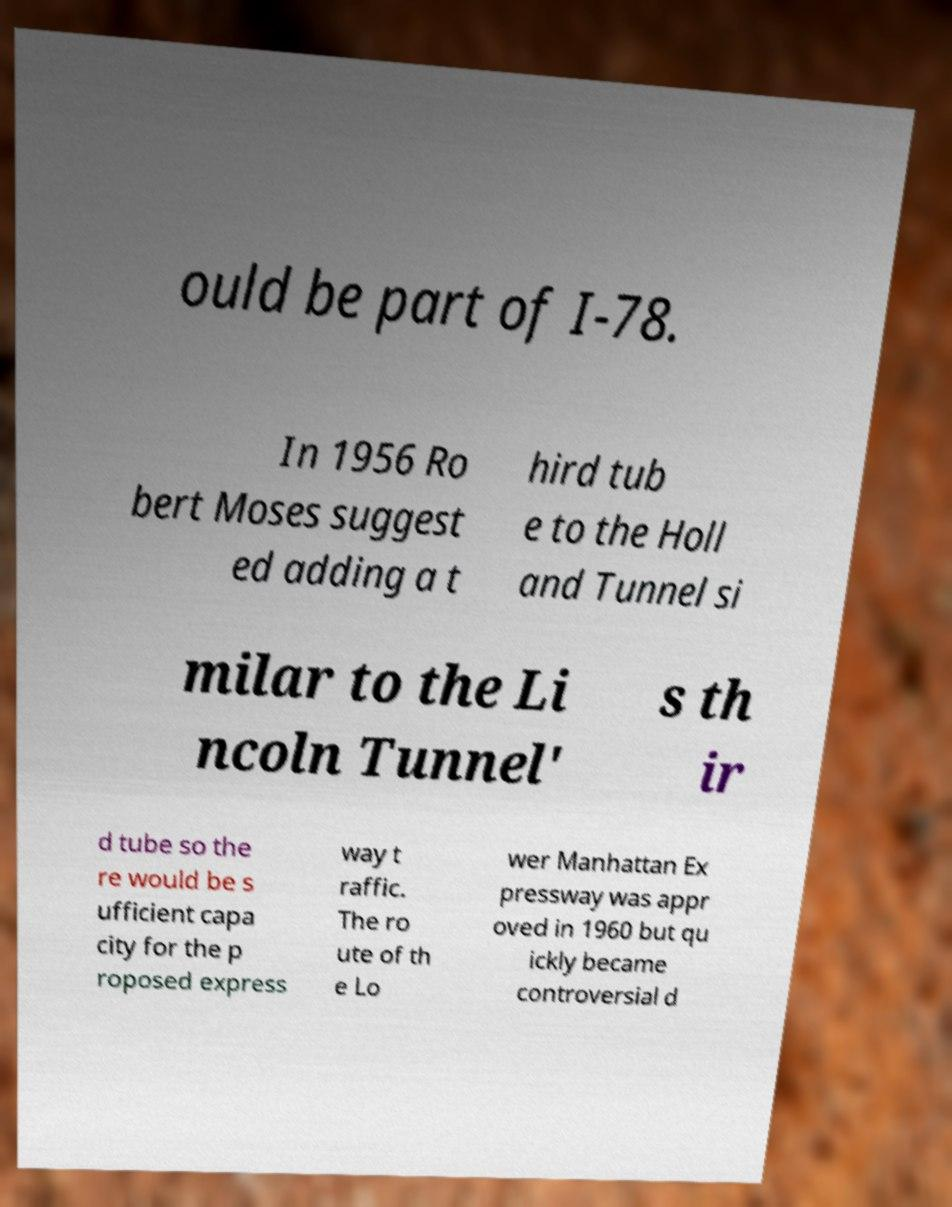There's text embedded in this image that I need extracted. Can you transcribe it verbatim? ould be part of I-78. In 1956 Ro bert Moses suggest ed adding a t hird tub e to the Holl and Tunnel si milar to the Li ncoln Tunnel' s th ir d tube so the re would be s ufficient capa city for the p roposed express way t raffic. The ro ute of th e Lo wer Manhattan Ex pressway was appr oved in 1960 but qu ickly became controversial d 